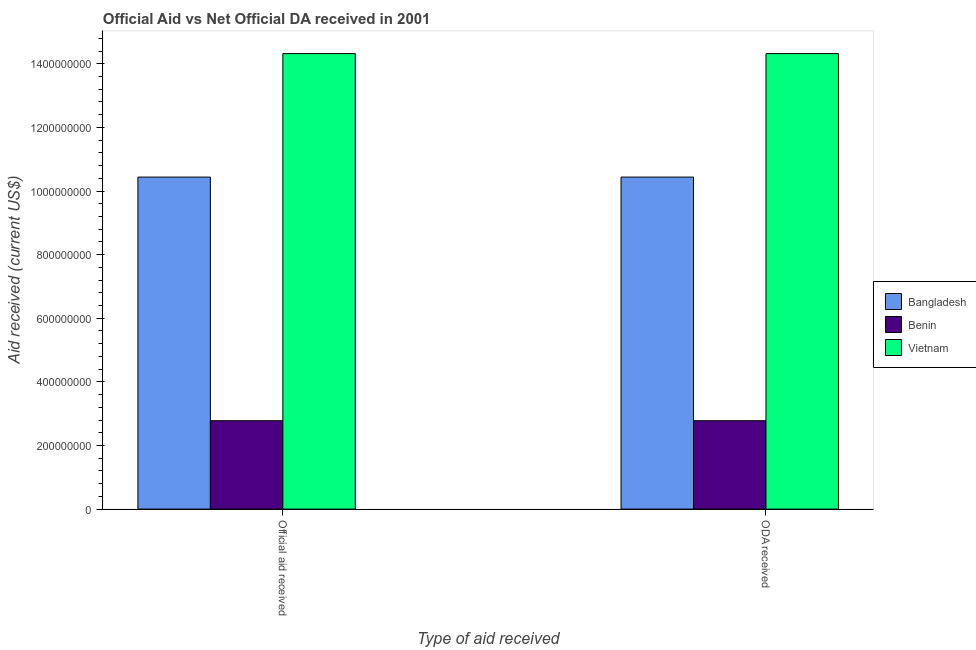How many groups of bars are there?
Keep it short and to the point. 2. Are the number of bars per tick equal to the number of legend labels?
Provide a succinct answer. Yes. How many bars are there on the 1st tick from the left?
Your answer should be compact. 3. How many bars are there on the 2nd tick from the right?
Keep it short and to the point. 3. What is the label of the 2nd group of bars from the left?
Make the answer very short. ODA received. What is the oda received in Benin?
Offer a terse response. 2.78e+08. Across all countries, what is the maximum oda received?
Your answer should be very brief. 1.43e+09. Across all countries, what is the minimum oda received?
Make the answer very short. 2.78e+08. In which country was the oda received maximum?
Your response must be concise. Vietnam. In which country was the oda received minimum?
Provide a succinct answer. Benin. What is the total oda received in the graph?
Ensure brevity in your answer.  2.75e+09. What is the difference between the official aid received in Benin and that in Vietnam?
Make the answer very short. -1.15e+09. What is the difference between the oda received in Vietnam and the official aid received in Bangladesh?
Your response must be concise. 3.88e+08. What is the average oda received per country?
Your answer should be very brief. 9.18e+08. What is the ratio of the official aid received in Vietnam to that in Bangladesh?
Provide a short and direct response. 1.37. In how many countries, is the oda received greater than the average oda received taken over all countries?
Offer a very short reply. 2. What does the 2nd bar from the left in ODA received represents?
Keep it short and to the point. Benin. What does the 1st bar from the right in Official aid received represents?
Provide a short and direct response. Vietnam. How many bars are there?
Your answer should be very brief. 6. Are all the bars in the graph horizontal?
Provide a succinct answer. No. How many countries are there in the graph?
Provide a succinct answer. 3. Are the values on the major ticks of Y-axis written in scientific E-notation?
Ensure brevity in your answer.  No. Does the graph contain grids?
Your answer should be compact. No. How many legend labels are there?
Make the answer very short. 3. What is the title of the graph?
Offer a terse response. Official Aid vs Net Official DA received in 2001 . What is the label or title of the X-axis?
Make the answer very short. Type of aid received. What is the label or title of the Y-axis?
Make the answer very short. Aid received (current US$). What is the Aid received (current US$) in Bangladesh in Official aid received?
Your answer should be very brief. 1.04e+09. What is the Aid received (current US$) of Benin in Official aid received?
Your answer should be compact. 2.78e+08. What is the Aid received (current US$) in Vietnam in Official aid received?
Provide a succinct answer. 1.43e+09. What is the Aid received (current US$) of Bangladesh in ODA received?
Provide a short and direct response. 1.04e+09. What is the Aid received (current US$) in Benin in ODA received?
Provide a short and direct response. 2.78e+08. What is the Aid received (current US$) of Vietnam in ODA received?
Give a very brief answer. 1.43e+09. Across all Type of aid received, what is the maximum Aid received (current US$) of Bangladesh?
Offer a terse response. 1.04e+09. Across all Type of aid received, what is the maximum Aid received (current US$) of Benin?
Your response must be concise. 2.78e+08. Across all Type of aid received, what is the maximum Aid received (current US$) in Vietnam?
Your response must be concise. 1.43e+09. Across all Type of aid received, what is the minimum Aid received (current US$) of Bangladesh?
Keep it short and to the point. 1.04e+09. Across all Type of aid received, what is the minimum Aid received (current US$) of Benin?
Offer a very short reply. 2.78e+08. Across all Type of aid received, what is the minimum Aid received (current US$) in Vietnam?
Give a very brief answer. 1.43e+09. What is the total Aid received (current US$) in Bangladesh in the graph?
Provide a short and direct response. 2.09e+09. What is the total Aid received (current US$) in Benin in the graph?
Give a very brief answer. 5.56e+08. What is the total Aid received (current US$) in Vietnam in the graph?
Provide a short and direct response. 2.86e+09. What is the difference between the Aid received (current US$) in Benin in Official aid received and that in ODA received?
Your response must be concise. 0. What is the difference between the Aid received (current US$) of Vietnam in Official aid received and that in ODA received?
Make the answer very short. 0. What is the difference between the Aid received (current US$) of Bangladesh in Official aid received and the Aid received (current US$) of Benin in ODA received?
Provide a short and direct response. 7.66e+08. What is the difference between the Aid received (current US$) in Bangladesh in Official aid received and the Aid received (current US$) in Vietnam in ODA received?
Your answer should be very brief. -3.88e+08. What is the difference between the Aid received (current US$) in Benin in Official aid received and the Aid received (current US$) in Vietnam in ODA received?
Give a very brief answer. -1.15e+09. What is the average Aid received (current US$) of Bangladesh per Type of aid received?
Provide a short and direct response. 1.04e+09. What is the average Aid received (current US$) in Benin per Type of aid received?
Ensure brevity in your answer.  2.78e+08. What is the average Aid received (current US$) in Vietnam per Type of aid received?
Offer a terse response. 1.43e+09. What is the difference between the Aid received (current US$) of Bangladesh and Aid received (current US$) of Benin in Official aid received?
Offer a very short reply. 7.66e+08. What is the difference between the Aid received (current US$) of Bangladesh and Aid received (current US$) of Vietnam in Official aid received?
Your answer should be very brief. -3.88e+08. What is the difference between the Aid received (current US$) of Benin and Aid received (current US$) of Vietnam in Official aid received?
Provide a succinct answer. -1.15e+09. What is the difference between the Aid received (current US$) of Bangladesh and Aid received (current US$) of Benin in ODA received?
Your answer should be very brief. 7.66e+08. What is the difference between the Aid received (current US$) of Bangladesh and Aid received (current US$) of Vietnam in ODA received?
Your answer should be compact. -3.88e+08. What is the difference between the Aid received (current US$) in Benin and Aid received (current US$) in Vietnam in ODA received?
Make the answer very short. -1.15e+09. What is the ratio of the Aid received (current US$) of Bangladesh in Official aid received to that in ODA received?
Ensure brevity in your answer.  1. What is the difference between the highest and the second highest Aid received (current US$) of Benin?
Provide a short and direct response. 0. What is the difference between the highest and the lowest Aid received (current US$) in Vietnam?
Ensure brevity in your answer.  0. 